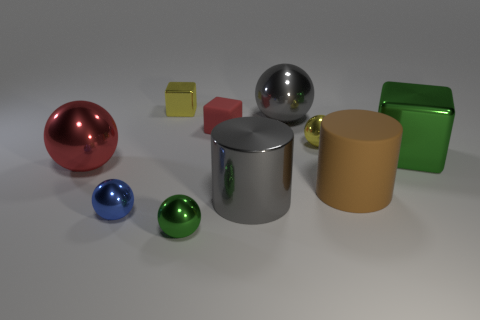How many metallic balls have the same size as the rubber cylinder?
Provide a short and direct response. 2. What shape is the large object that is the same color as the matte block?
Keep it short and to the point. Sphere. Are there any other red objects that have the same shape as the big rubber object?
Give a very brief answer. No. There is a matte thing that is the same size as the green cube; what is its color?
Provide a succinct answer. Brown. What color is the large cylinder left of the matte object in front of the big red shiny ball?
Your answer should be compact. Gray. Do the large metallic ball that is to the right of the red cube and the big rubber cylinder have the same color?
Keep it short and to the point. No. There is a green shiny object behind the green metallic object that is on the left side of the tiny ball right of the small red object; what shape is it?
Your response must be concise. Cube. There is a green shiny object that is in front of the blue sphere; what number of small metal balls are behind it?
Provide a short and direct response. 2. Are the green block and the brown thing made of the same material?
Your answer should be compact. No. How many yellow objects are behind the small yellow metallic thing that is in front of the small yellow metal cube that is left of the large gray metallic cylinder?
Provide a short and direct response. 1. 